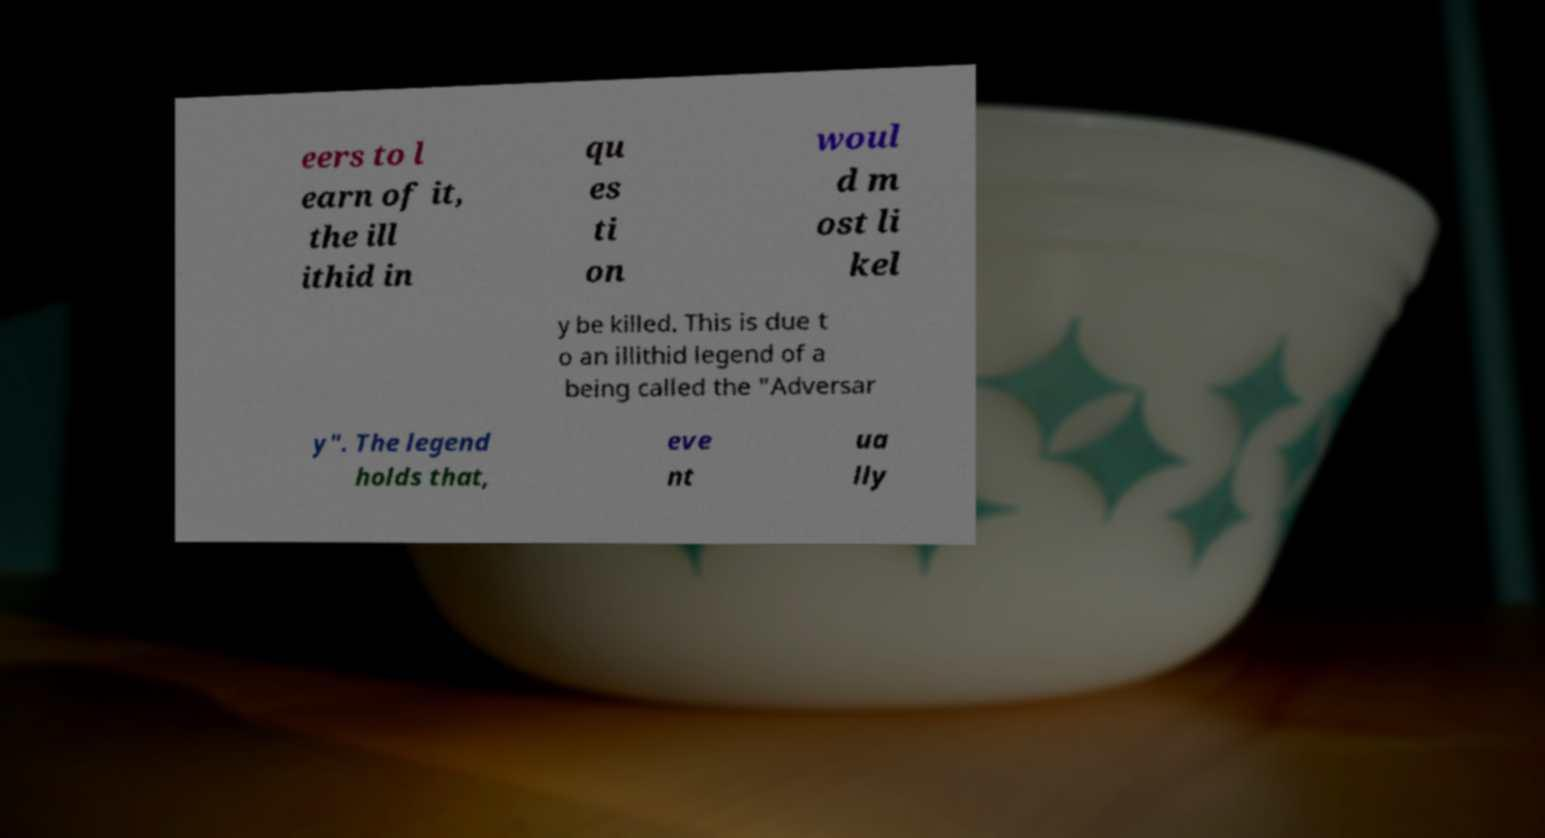There's text embedded in this image that I need extracted. Can you transcribe it verbatim? eers to l earn of it, the ill ithid in qu es ti on woul d m ost li kel y be killed. This is due t o an illithid legend of a being called the "Adversar y". The legend holds that, eve nt ua lly 